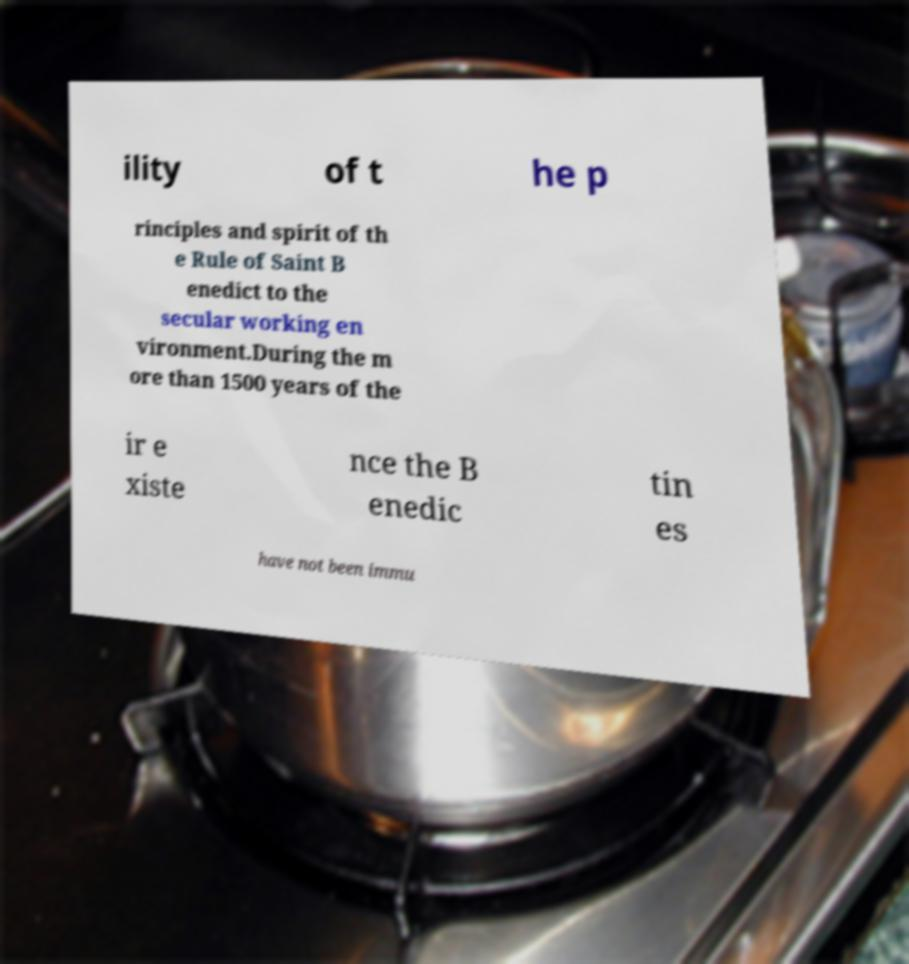Can you read and provide the text displayed in the image?This photo seems to have some interesting text. Can you extract and type it out for me? ility of t he p rinciples and spirit of th e Rule of Saint B enedict to the secular working en vironment.During the m ore than 1500 years of the ir e xiste nce the B enedic tin es have not been immu 